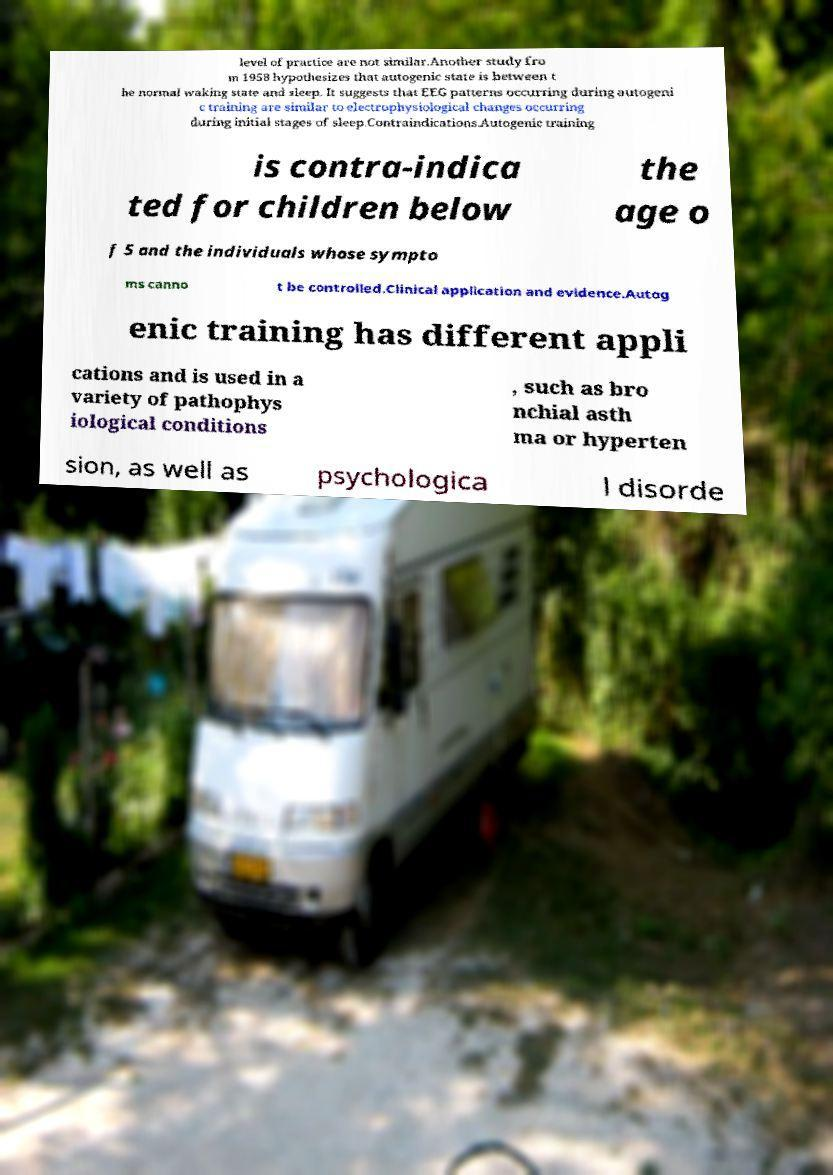Can you accurately transcribe the text from the provided image for me? level of practice are not similar.Another study fro m 1958 hypothesizes that autogenic state is between t he normal waking state and sleep. It suggests that EEG patterns occurring during autogeni c training are similar to electrophysiological changes occurring during initial stages of sleep.Contraindications.Autogenic training is contra-indica ted for children below the age o f 5 and the individuals whose sympto ms canno t be controlled.Clinical application and evidence.Autog enic training has different appli cations and is used in a variety of pathophys iological conditions , such as bro nchial asth ma or hyperten sion, as well as psychologica l disorde 